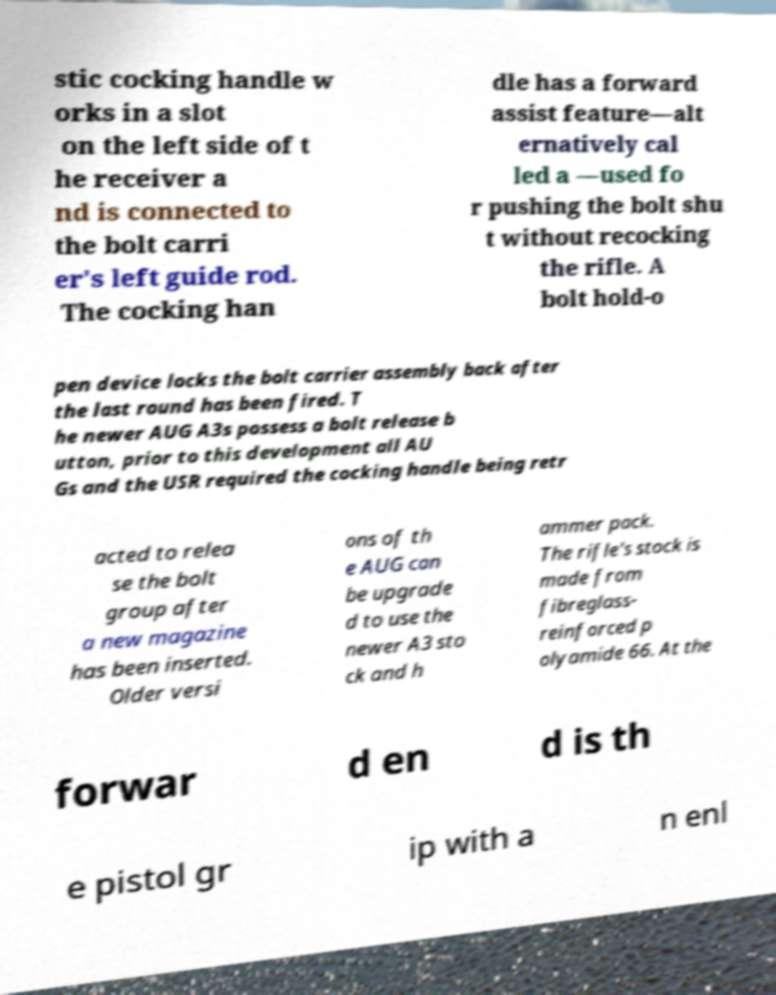Could you extract and type out the text from this image? stic cocking handle w orks in a slot on the left side of t he receiver a nd is connected to the bolt carri er's left guide rod. The cocking han dle has a forward assist feature—alt ernatively cal led a —used fo r pushing the bolt shu t without recocking the rifle. A bolt hold-o pen device locks the bolt carrier assembly back after the last round has been fired. T he newer AUG A3s possess a bolt release b utton, prior to this development all AU Gs and the USR required the cocking handle being retr acted to relea se the bolt group after a new magazine has been inserted. Older versi ons of th e AUG can be upgrade d to use the newer A3 sto ck and h ammer pack. The rifle's stock is made from fibreglass- reinforced p olyamide 66. At the forwar d en d is th e pistol gr ip with a n enl 